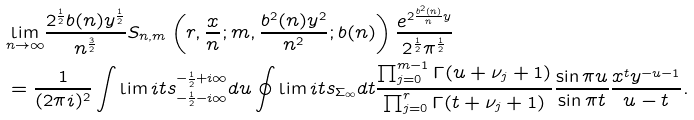<formula> <loc_0><loc_0><loc_500><loc_500>& \underset { n \rightarrow \infty } { \lim } \frac { 2 ^ { \frac { 1 } { 2 } } b ( n ) y ^ { \frac { 1 } { 2 } } } { n ^ { \frac { 3 } { 2 } } } S _ { n , m } \left ( r , \frac { x } { n } ; m , \frac { b ^ { 2 } ( n ) y ^ { 2 } } { n ^ { 2 } } ; b ( n ) \right ) \frac { e ^ { 2 \frac { b ^ { 2 } ( n ) } { n } y } } { 2 ^ { \frac { 1 } { 2 } } \pi ^ { \frac { 1 } { 2 } } } \\ & = \frac { 1 } { ( 2 \pi i ) ^ { 2 } } \int \lim i t s _ { - \frac { 1 } { 2 } - i \infty } ^ { - \frac { 1 } { 2 } + i \infty } d u \oint \lim i t s _ { \Sigma _ { \infty } } d t \frac { \prod _ { j = 0 } ^ { m - 1 } \Gamma ( u + \nu _ { j } + 1 ) } { \prod _ { j = 0 } ^ { r } \Gamma ( t + \nu _ { j } + 1 ) } \frac { \sin \pi u } { \sin \pi t } \frac { x ^ { t } y ^ { - u - 1 } } { u - t } .</formula> 